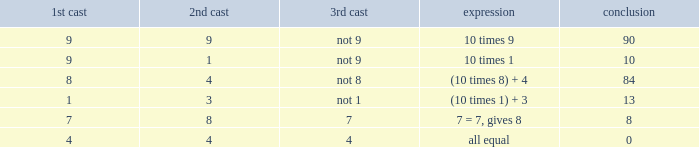What is the equation where the 3rd throw is 7? 7 = 7, gives 8. 